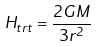Convert formula to latex. <formula><loc_0><loc_0><loc_500><loc_500>H _ { t r t } = \frac { 2 G M } { 3 r ^ { 2 } }</formula> 